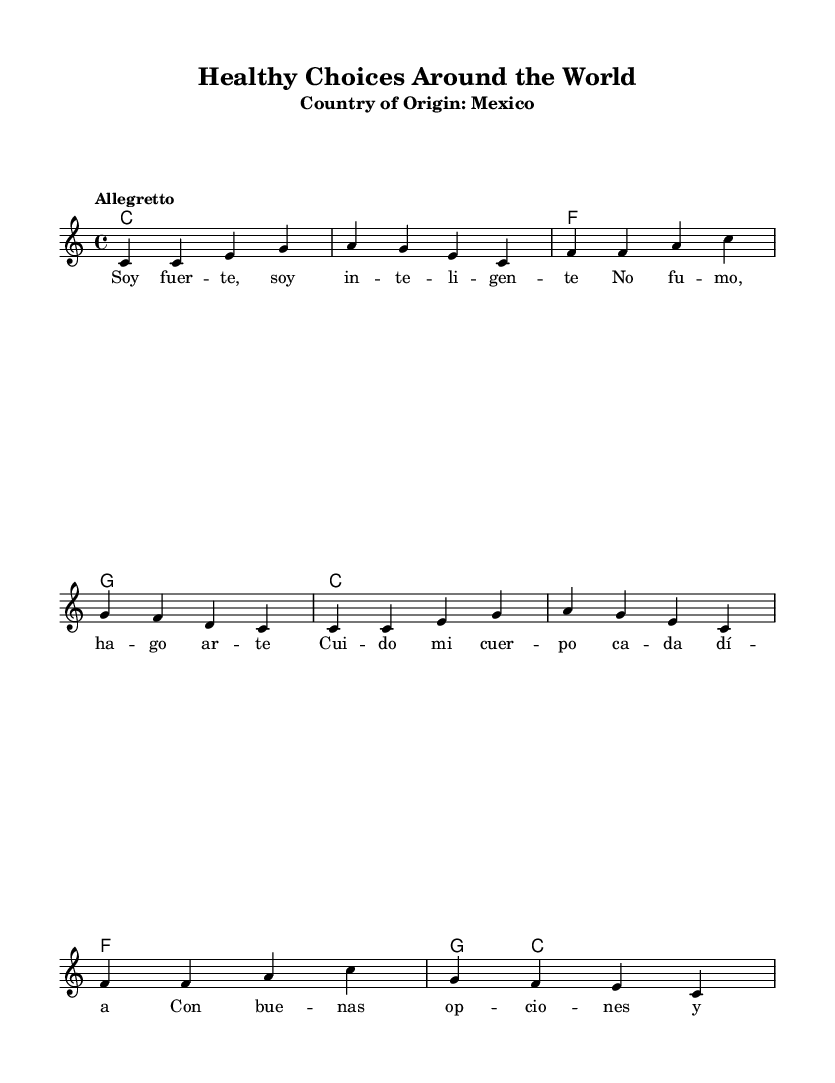What is the key signature of this music? The key signature is C major, which is indicated by the absence of sharps or flats on the staff.
Answer: C major What is the time signature of the piece? The time signature is 4/4, as seen in the beginning part of the score where it shows four beats in a measure.
Answer: 4/4 What is the tempo marking for this piece? The tempo marking is "Allegretto," which indicates a moderately fast pace for the performance of the music.
Answer: Allegretto How many measures are in the melody? There are eight measures in the melody, as counted from the beginning to the end of the melody section.
Answer: Eight What is the lyric's theme in this song? The theme of the lyrics revolves around making positive choices and being strong and intelligent, which aligns with the song's message.
Answer: Making positive choices What type of music does this piece represent? This piece represents World Music, specifically educational children's songs from Mexico, designed to promote healthy choices.
Answer: World Music Which chords accompany the melody? The chords accompanying the melody are C, F, and G, as indicated in the chord changes section of the score.
Answer: C, F, G 